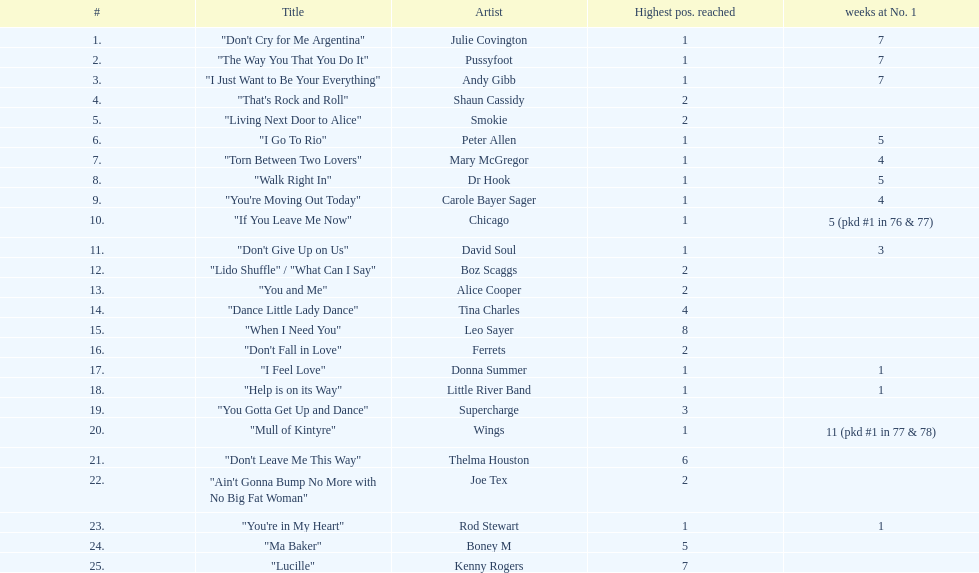How many songs in the table achieved solely the number 2 position? 6. 